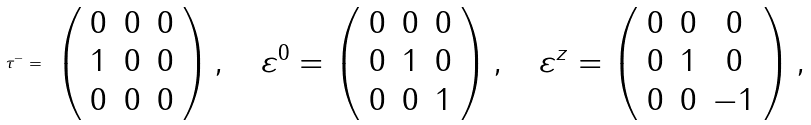<formula> <loc_0><loc_0><loc_500><loc_500>\tau ^ { - } = \begin{array} { c } { { \left ( \begin{array} { c c c } { 0 } & { 0 } & { 0 } \\ { 1 } & { 0 } & { 0 } \\ { 0 } & { 0 } & { 0 } \end{array} \right ) , \quad \varepsilon ^ { 0 } = \left ( \begin{array} { c c c } { 0 } & { 0 } & { 0 } \\ { 0 } & { 1 } & { 0 } \\ { 0 } & { 0 } & { 1 } \end{array} \right ) , \quad \varepsilon ^ { z } = \left ( \begin{array} { c c c } { 0 } & { 0 } & { 0 } \\ { 0 } & { 1 } & { 0 } \\ { 0 } & { 0 } & { - 1 } \end{array} \right ) , } } \end{array}</formula> 